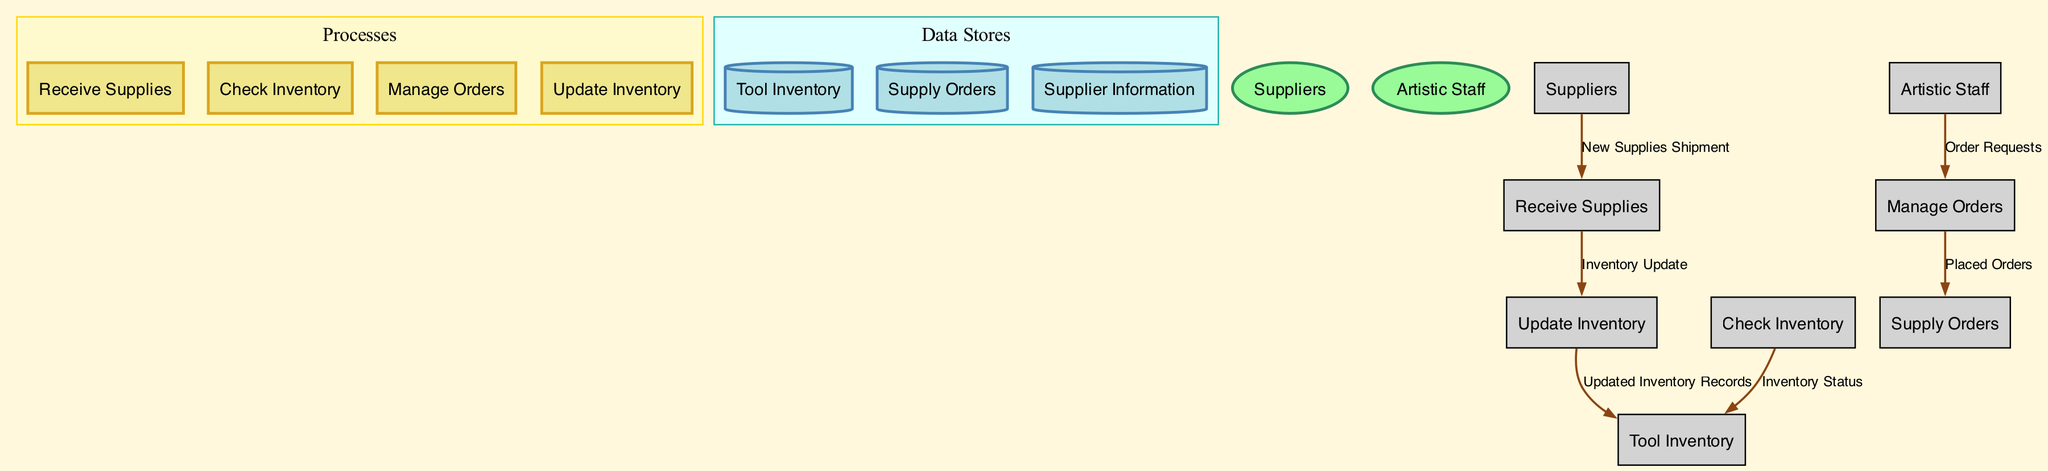What is the name of the process that handles new supplies? The process responsible for handling new supplies is labeled as "Receive Supplies." It can be identified in the diagram as one of the main processes, specifically designated to manage incoming shipments.
Answer: Receive Supplies How many external entities are shown in the diagram? The diagram includes two external entities: "Suppliers" and "Artistic Staff." These are represented as ellipses in the diagram, clearly indicating their role as sources or users of information within the system.
Answer: 2 Which data store contains the records of tool quantities and status? The data store labeled as "Tool Inventory" is specifically designated to hold records related to carving tools, including their quantities and status. This can be easily identified within the data stores section of the diagram.
Answer: Tool Inventory What is the data flow from "Received Supplies" to "Update Inventory"? The data flow from "Receive Supplies" to "Update Inventory" is labeled as "Inventory Update." This data flow signifies the transfer of information regarding the received supplies so that the inventory can be accurately updated.
Answer: Inventory Update What process does "Order Requests" come from? "Order Requests" originates from the "Artistic Staff," which directly communicates its need for new supplies to the process managing orders, which is "Manage Orders." This highlights the interaction between the artistic team and the order management process.
Answer: Artistic Staff In total, how many processes are defined in the diagram? The diagram defines four distinct processes: "Receive Supplies," "Check Inventory," "Manage Orders," and "Update Inventory." These processes are a central part of inventory management workflows and are represented in rectangular shapes.
Answer: 4 What does the data flow labeled "Placed Orders" connect? The "Placed Orders" data flow connects the "Manage Orders" process with the "Supply Orders" data store. This relationship indicates the flow of information related to orders that have been officially placed with suppliers.
Answer: Manage Orders and Supply Orders What type of information is stored in "Supplier Information"? The "Supplier Information" data store contains contact and product information regarding suppliers of carving tools and materials. This information assists in managing supplier relationships and order placements.
Answer: Contact and product information How does "Check Inventory" affect the "Tool Inventory"? The "Check Inventory" process sends "Inventory Status" to the "Tool Inventory," which updates the status and quantities of tools within the inventory system. This reflects the ongoing monitoring and evaluation of available tools.
Answer: Inventory Status 